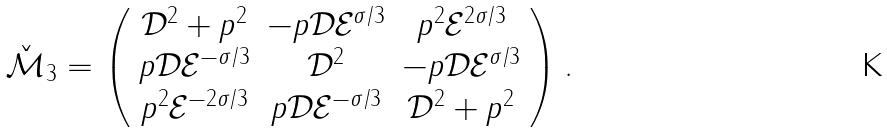Convert formula to latex. <formula><loc_0><loc_0><loc_500><loc_500>\check { \mathcal { M } } _ { 3 } = \left ( \begin{array} { c c c } \mathcal { D } ^ { 2 } + p ^ { 2 } & - p \mathcal { D } \mathcal { E } ^ { \sigma / 3 } & p ^ { 2 } \mathcal { E } ^ { 2 \sigma / 3 } \\ p \mathcal { D } \mathcal { E } ^ { - \sigma / 3 } & \mathcal { D } ^ { 2 } & - p \mathcal { D } \mathcal { E } ^ { \sigma / 3 } \\ p ^ { 2 } \mathcal { E } ^ { - 2 \sigma / 3 } & p \mathcal { D } \mathcal { E } ^ { - \sigma / 3 } & \mathcal { D } ^ { 2 } + p ^ { 2 } \end{array} \right ) .</formula> 